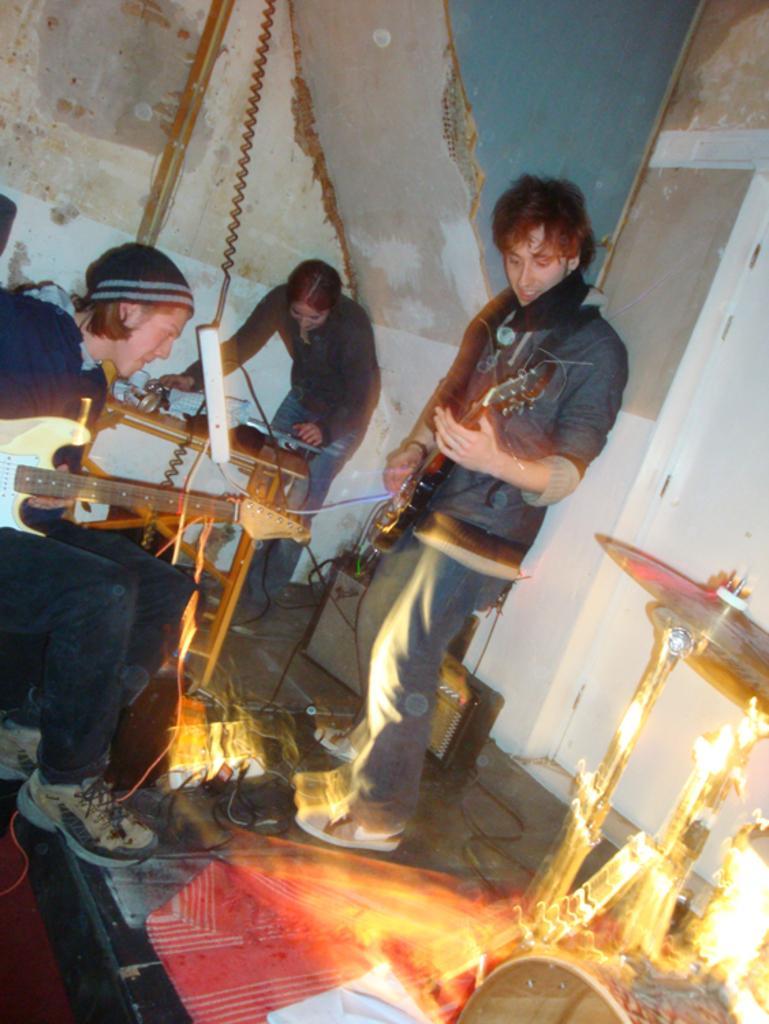Could you give a brief overview of what you see in this image? In the center of the image there is a person holding a guitar and standing on dais. On the right side of the image we can see a musical instruments. On the left side of the image we can see persons and musical instruments. In the background we can see table, person and wall. 